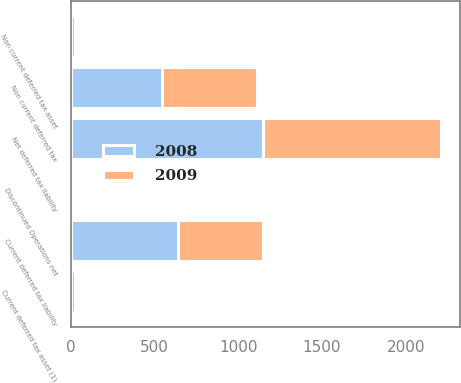Convert chart. <chart><loc_0><loc_0><loc_500><loc_500><stacked_bar_chart><ecel><fcel>Current deferred tax asset (1)<fcel>Non current deferred tax asset<fcel>Current deferred tax liability<fcel>Non current deferred tax<fcel>Discontinued Operations net<fcel>Net deferred tax liability<nl><fcel>2008<fcel>22.5<fcel>24.2<fcel>642<fcel>541<fcel>8.4<fcel>1144.7<nl><fcel>2009<fcel>8.2<fcel>11.2<fcel>506.6<fcel>568.5<fcel>11.8<fcel>1067.5<nl></chart> 